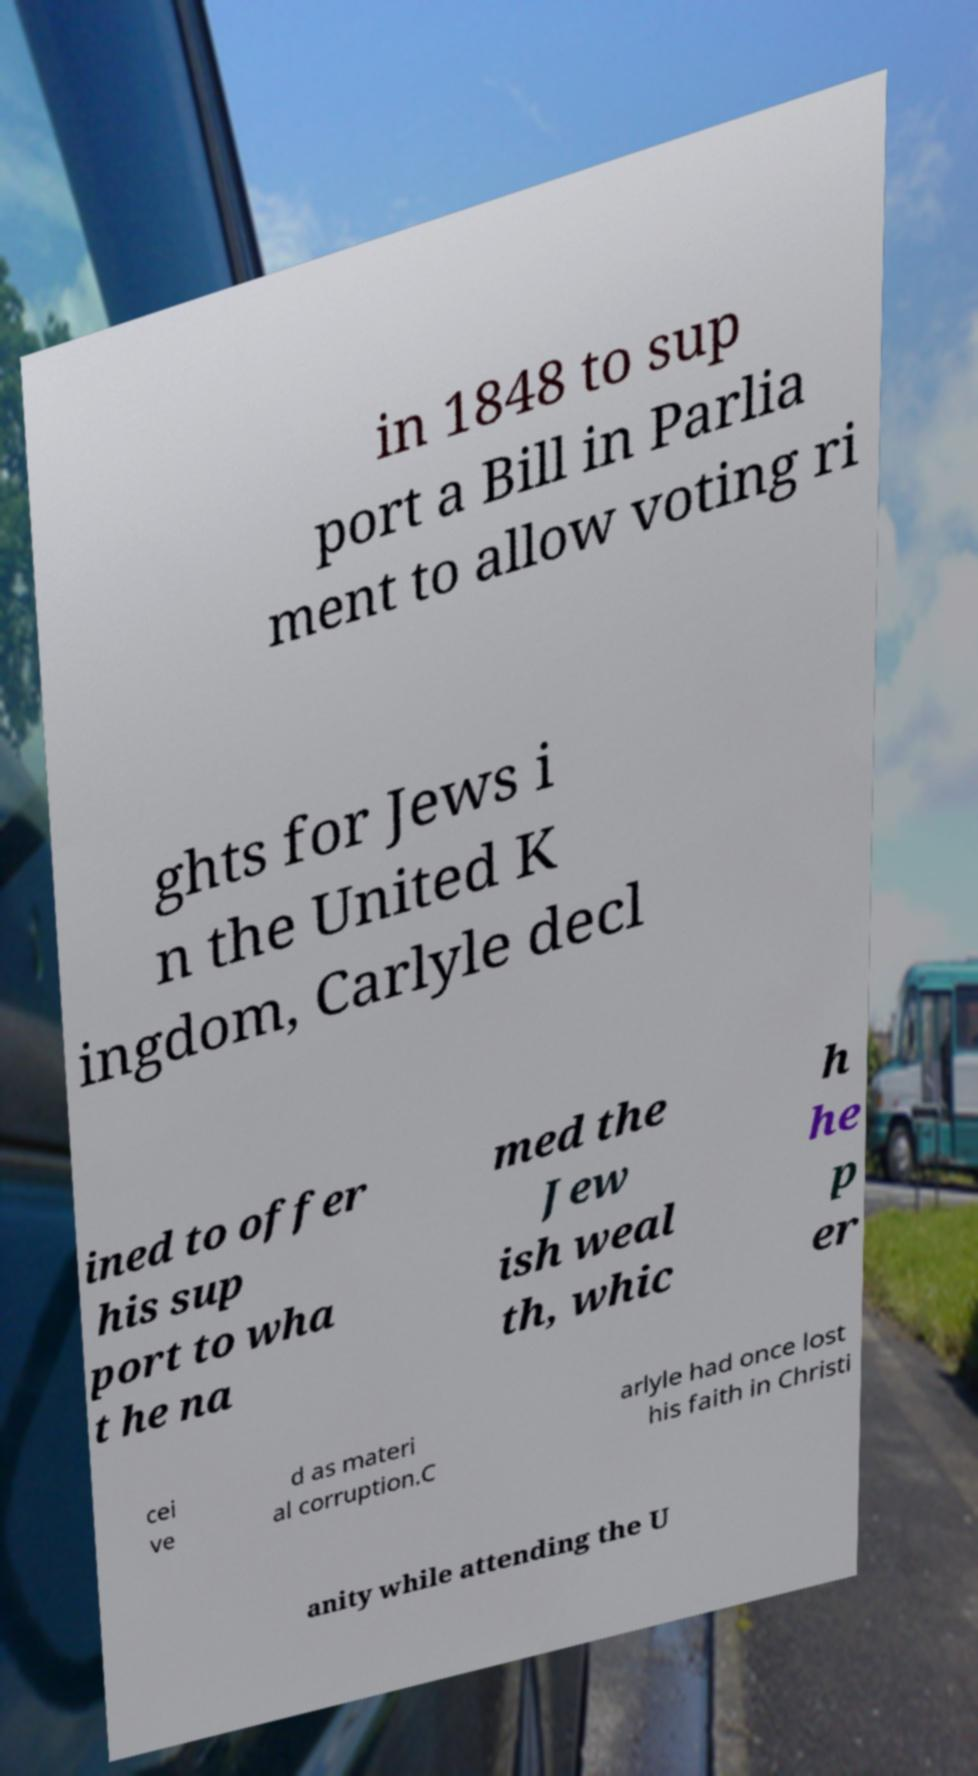Could you extract and type out the text from this image? in 1848 to sup port a Bill in Parlia ment to allow voting ri ghts for Jews i n the United K ingdom, Carlyle decl ined to offer his sup port to wha t he na med the Jew ish weal th, whic h he p er cei ve d as materi al corruption.C arlyle had once lost his faith in Christi anity while attending the U 